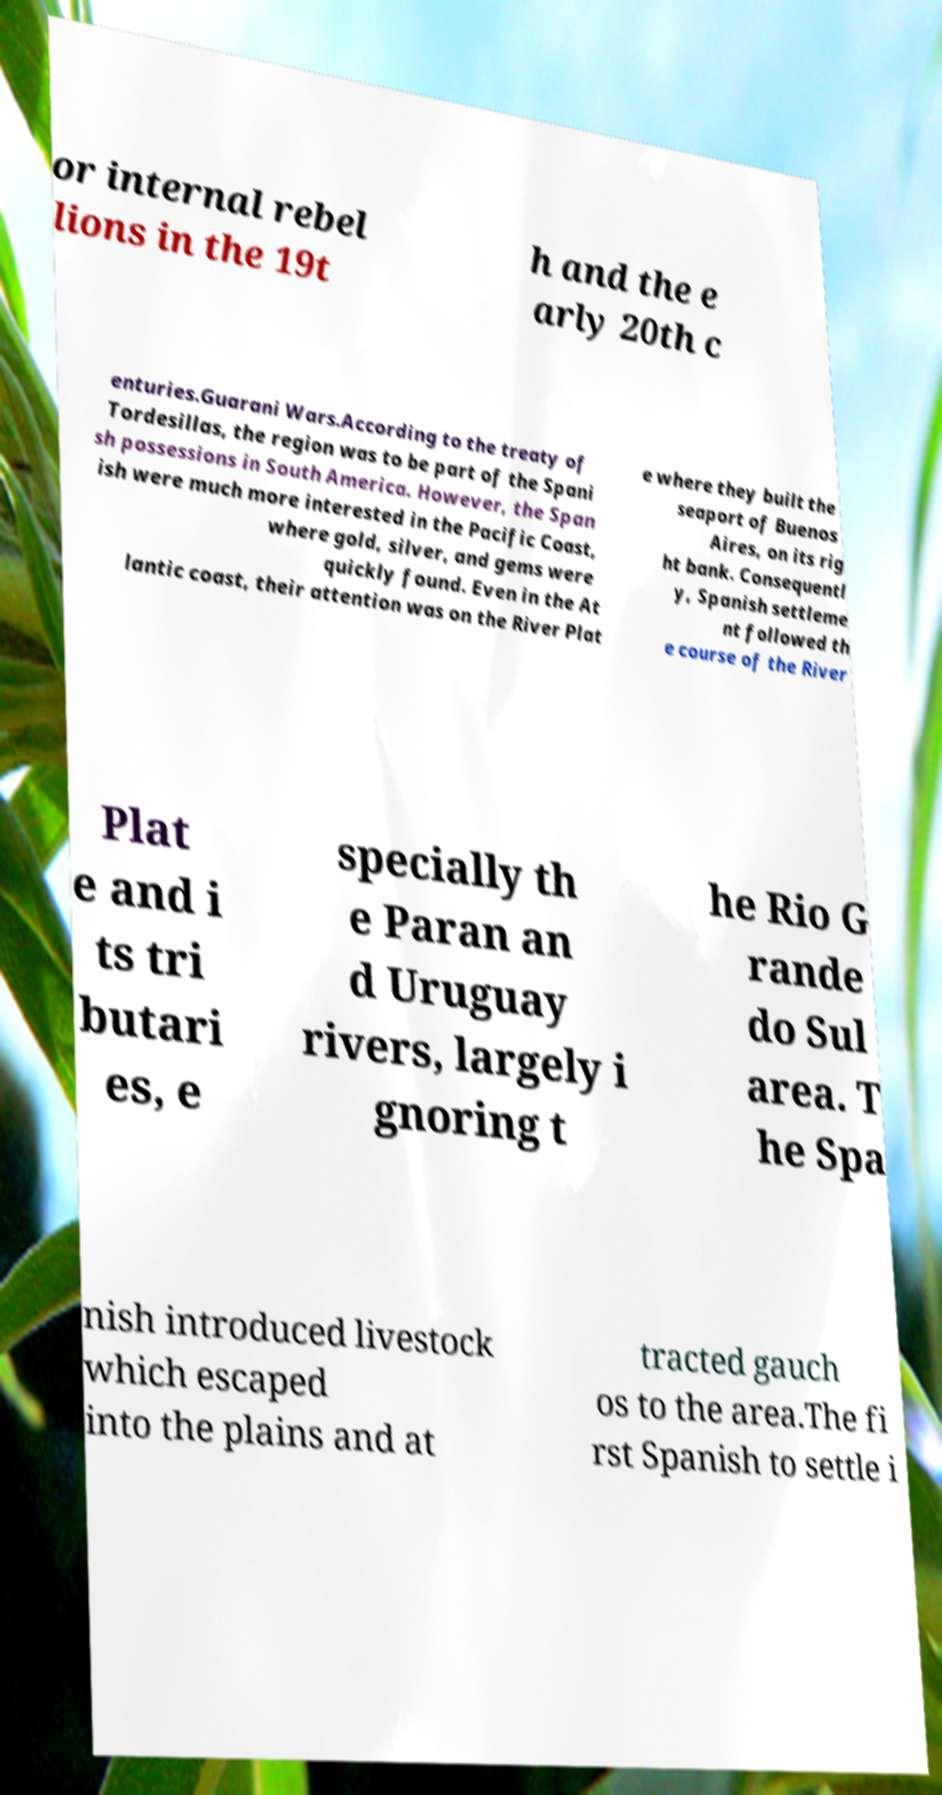Could you extract and type out the text from this image? or internal rebel lions in the 19t h and the e arly 20th c enturies.Guarani Wars.According to the treaty of Tordesillas, the region was to be part of the Spani sh possessions in South America. However, the Span ish were much more interested in the Pacific Coast, where gold, silver, and gems were quickly found. Even in the At lantic coast, their attention was on the River Plat e where they built the seaport of Buenos Aires, on its rig ht bank. Consequentl y, Spanish settleme nt followed th e course of the River Plat e and i ts tri butari es, e specially th e Paran an d Uruguay rivers, largely i gnoring t he Rio G rande do Sul area. T he Spa nish introduced livestock which escaped into the plains and at tracted gauch os to the area.The fi rst Spanish to settle i 